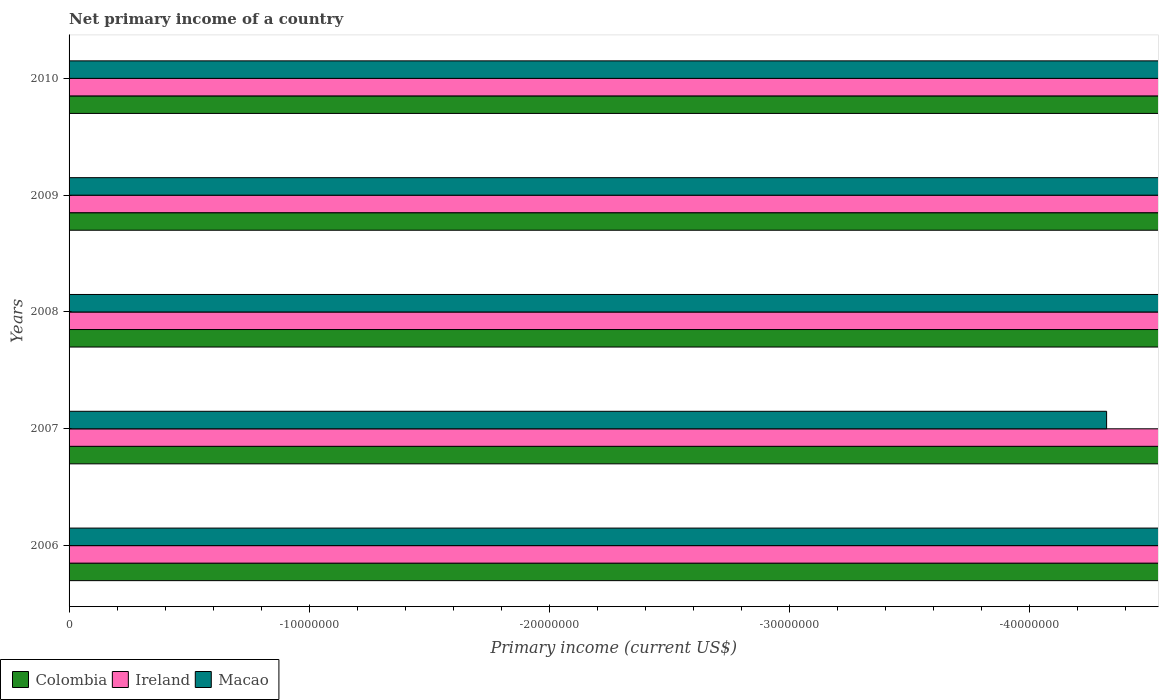How many different coloured bars are there?
Keep it short and to the point. 0. Are the number of bars per tick equal to the number of legend labels?
Make the answer very short. No. How many bars are there on the 3rd tick from the bottom?
Keep it short and to the point. 0. What is the label of the 5th group of bars from the top?
Your response must be concise. 2006. Across all years, what is the minimum primary income in Macao?
Make the answer very short. 0. What is the difference between the primary income in Macao in 2009 and the primary income in Ireland in 2008?
Offer a terse response. 0. In how many years, is the primary income in Macao greater than the average primary income in Macao taken over all years?
Keep it short and to the point. 0. Is it the case that in every year, the sum of the primary income in Colombia and primary income in Ireland is greater than the primary income in Macao?
Make the answer very short. No. What is the difference between two consecutive major ticks on the X-axis?
Your answer should be compact. 1.00e+07. Does the graph contain grids?
Provide a short and direct response. No. How many legend labels are there?
Provide a succinct answer. 3. How are the legend labels stacked?
Make the answer very short. Horizontal. What is the title of the graph?
Your response must be concise. Net primary income of a country. What is the label or title of the X-axis?
Give a very brief answer. Primary income (current US$). What is the Primary income (current US$) in Macao in 2007?
Make the answer very short. 0. What is the Primary income (current US$) in Colombia in 2008?
Your answer should be very brief. 0. What is the Primary income (current US$) in Ireland in 2008?
Your answer should be compact. 0. What is the Primary income (current US$) of Macao in 2008?
Provide a succinct answer. 0. What is the Primary income (current US$) of Ireland in 2009?
Keep it short and to the point. 0. What is the Primary income (current US$) in Macao in 2009?
Give a very brief answer. 0. What is the Primary income (current US$) in Colombia in 2010?
Your answer should be very brief. 0. What is the Primary income (current US$) in Macao in 2010?
Your answer should be very brief. 0. What is the total Primary income (current US$) in Colombia in the graph?
Provide a short and direct response. 0. What is the total Primary income (current US$) of Ireland in the graph?
Keep it short and to the point. 0. What is the total Primary income (current US$) of Macao in the graph?
Your response must be concise. 0. 